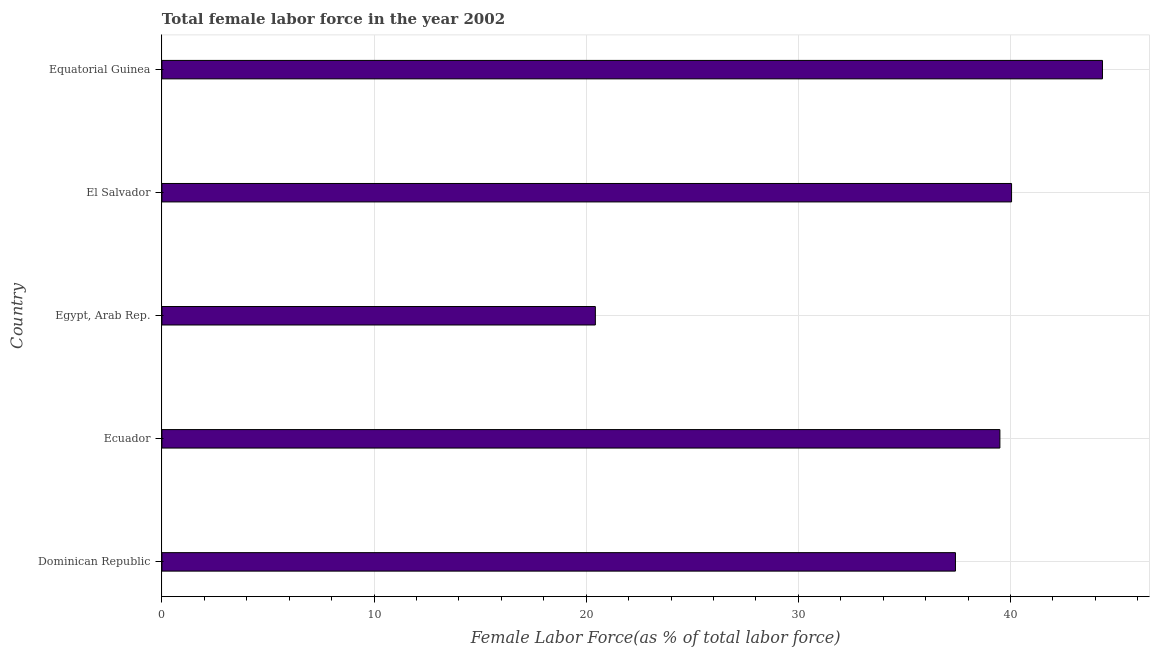What is the title of the graph?
Give a very brief answer. Total female labor force in the year 2002. What is the label or title of the X-axis?
Make the answer very short. Female Labor Force(as % of total labor force). What is the total female labor force in Egypt, Arab Rep.?
Make the answer very short. 20.43. Across all countries, what is the maximum total female labor force?
Offer a very short reply. 44.33. Across all countries, what is the minimum total female labor force?
Your answer should be very brief. 20.43. In which country was the total female labor force maximum?
Make the answer very short. Equatorial Guinea. In which country was the total female labor force minimum?
Ensure brevity in your answer.  Egypt, Arab Rep. What is the sum of the total female labor force?
Provide a succinct answer. 181.72. What is the difference between the total female labor force in Egypt, Arab Rep. and El Salvador?
Give a very brief answer. -19.62. What is the average total female labor force per country?
Ensure brevity in your answer.  36.34. What is the median total female labor force?
Your answer should be compact. 39.5. In how many countries, is the total female labor force greater than 38 %?
Make the answer very short. 3. What is the ratio of the total female labor force in Dominican Republic to that in Ecuador?
Provide a short and direct response. 0.95. What is the difference between the highest and the second highest total female labor force?
Provide a short and direct response. 4.29. Is the sum of the total female labor force in Dominican Republic and El Salvador greater than the maximum total female labor force across all countries?
Offer a terse response. Yes. What is the difference between the highest and the lowest total female labor force?
Provide a short and direct response. 23.9. In how many countries, is the total female labor force greater than the average total female labor force taken over all countries?
Give a very brief answer. 4. Are all the bars in the graph horizontal?
Offer a terse response. Yes. How many countries are there in the graph?
Ensure brevity in your answer.  5. What is the difference between two consecutive major ticks on the X-axis?
Ensure brevity in your answer.  10. Are the values on the major ticks of X-axis written in scientific E-notation?
Give a very brief answer. No. What is the Female Labor Force(as % of total labor force) of Dominican Republic?
Provide a succinct answer. 37.41. What is the Female Labor Force(as % of total labor force) of Ecuador?
Give a very brief answer. 39.5. What is the Female Labor Force(as % of total labor force) of Egypt, Arab Rep.?
Provide a succinct answer. 20.43. What is the Female Labor Force(as % of total labor force) in El Salvador?
Give a very brief answer. 40.05. What is the Female Labor Force(as % of total labor force) in Equatorial Guinea?
Provide a succinct answer. 44.33. What is the difference between the Female Labor Force(as % of total labor force) in Dominican Republic and Ecuador?
Make the answer very short. -2.09. What is the difference between the Female Labor Force(as % of total labor force) in Dominican Republic and Egypt, Arab Rep.?
Ensure brevity in your answer.  16.97. What is the difference between the Female Labor Force(as % of total labor force) in Dominican Republic and El Salvador?
Your response must be concise. -2.64. What is the difference between the Female Labor Force(as % of total labor force) in Dominican Republic and Equatorial Guinea?
Ensure brevity in your answer.  -6.93. What is the difference between the Female Labor Force(as % of total labor force) in Ecuador and Egypt, Arab Rep.?
Your answer should be very brief. 19.07. What is the difference between the Female Labor Force(as % of total labor force) in Ecuador and El Salvador?
Your answer should be very brief. -0.55. What is the difference between the Female Labor Force(as % of total labor force) in Ecuador and Equatorial Guinea?
Keep it short and to the point. -4.83. What is the difference between the Female Labor Force(as % of total labor force) in Egypt, Arab Rep. and El Salvador?
Ensure brevity in your answer.  -19.62. What is the difference between the Female Labor Force(as % of total labor force) in Egypt, Arab Rep. and Equatorial Guinea?
Your answer should be very brief. -23.9. What is the difference between the Female Labor Force(as % of total labor force) in El Salvador and Equatorial Guinea?
Keep it short and to the point. -4.28. What is the ratio of the Female Labor Force(as % of total labor force) in Dominican Republic to that in Ecuador?
Your response must be concise. 0.95. What is the ratio of the Female Labor Force(as % of total labor force) in Dominican Republic to that in Egypt, Arab Rep.?
Provide a short and direct response. 1.83. What is the ratio of the Female Labor Force(as % of total labor force) in Dominican Republic to that in El Salvador?
Offer a very short reply. 0.93. What is the ratio of the Female Labor Force(as % of total labor force) in Dominican Republic to that in Equatorial Guinea?
Ensure brevity in your answer.  0.84. What is the ratio of the Female Labor Force(as % of total labor force) in Ecuador to that in Egypt, Arab Rep.?
Your response must be concise. 1.93. What is the ratio of the Female Labor Force(as % of total labor force) in Ecuador to that in El Salvador?
Keep it short and to the point. 0.99. What is the ratio of the Female Labor Force(as % of total labor force) in Ecuador to that in Equatorial Guinea?
Offer a terse response. 0.89. What is the ratio of the Female Labor Force(as % of total labor force) in Egypt, Arab Rep. to that in El Salvador?
Keep it short and to the point. 0.51. What is the ratio of the Female Labor Force(as % of total labor force) in Egypt, Arab Rep. to that in Equatorial Guinea?
Your answer should be very brief. 0.46. What is the ratio of the Female Labor Force(as % of total labor force) in El Salvador to that in Equatorial Guinea?
Provide a succinct answer. 0.9. 